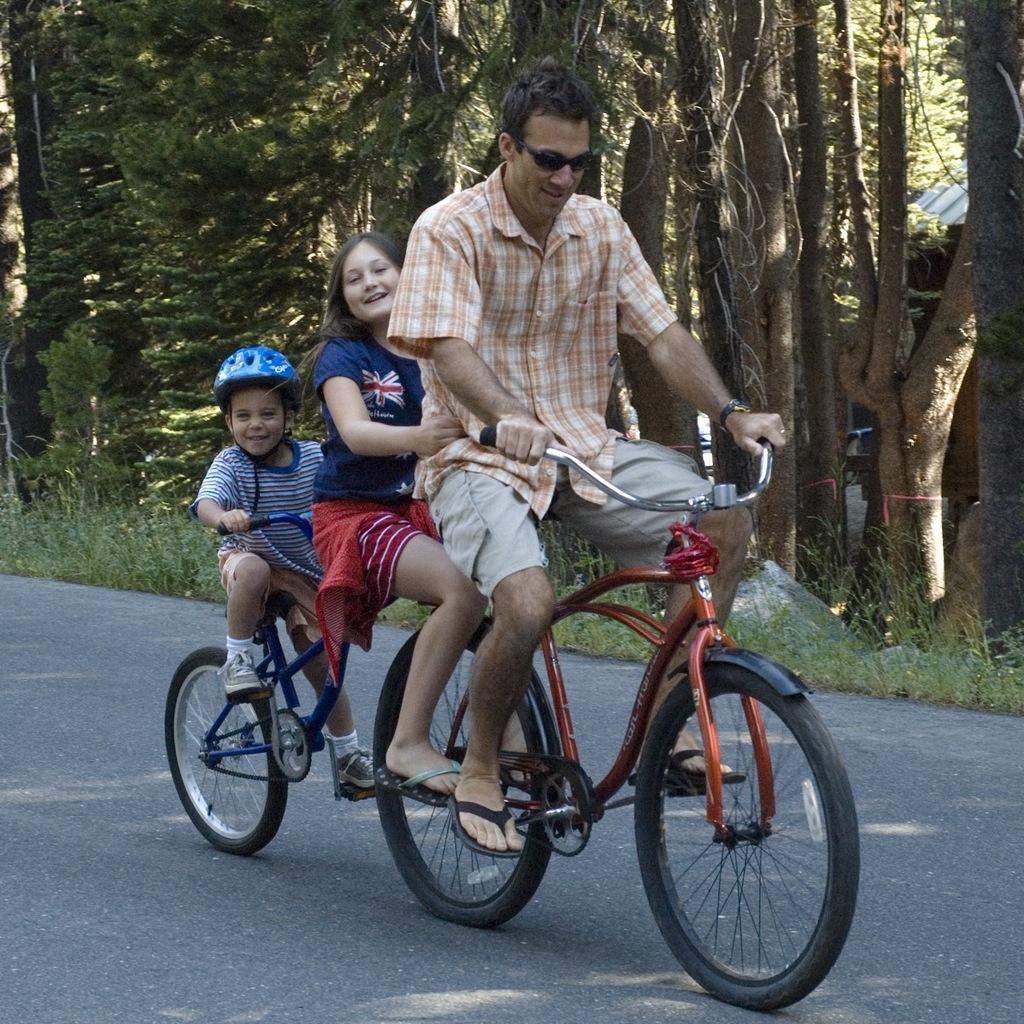Can you describe this image briefly? This picture shows three people riding a bicycle and we see few trees on the side 